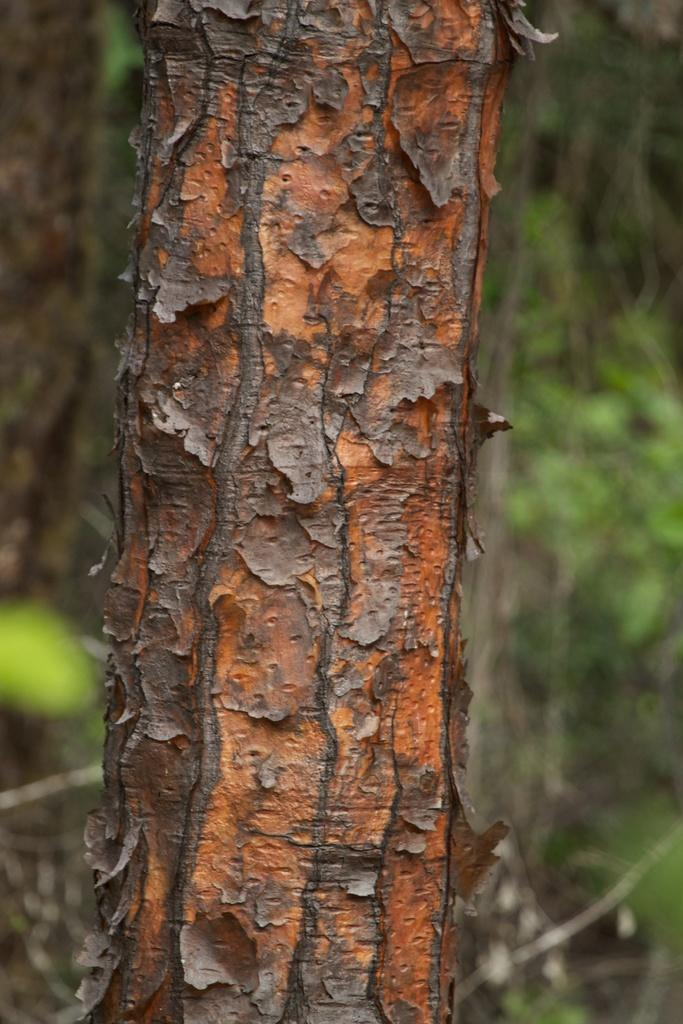What is the main object in the center of the image? There is a trunk in the center of the image. What can be seen in the background of the image? There is greenery in the background of the image. How many ducks are swimming in the silver pond in the image? There are no ducks or silver pond present in the image. 